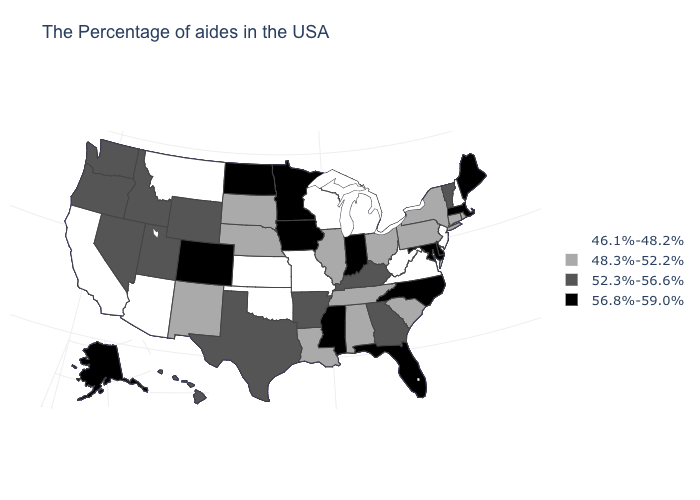What is the value of Pennsylvania?
Give a very brief answer. 48.3%-52.2%. What is the value of Wyoming?
Give a very brief answer. 52.3%-56.6%. Name the states that have a value in the range 56.8%-59.0%?
Answer briefly. Maine, Massachusetts, Delaware, Maryland, North Carolina, Florida, Indiana, Mississippi, Minnesota, Iowa, North Dakota, Colorado, Alaska. Does Tennessee have the same value as Vermont?
Keep it brief. No. What is the value of Montana?
Keep it brief. 46.1%-48.2%. How many symbols are there in the legend?
Concise answer only. 4. What is the lowest value in the USA?
Write a very short answer. 46.1%-48.2%. Does Mississippi have the lowest value in the South?
Write a very short answer. No. What is the lowest value in the MidWest?
Be succinct. 46.1%-48.2%. What is the highest value in the USA?
Be succinct. 56.8%-59.0%. Name the states that have a value in the range 52.3%-56.6%?
Answer briefly. Vermont, Georgia, Kentucky, Arkansas, Texas, Wyoming, Utah, Idaho, Nevada, Washington, Oregon, Hawaii. Which states hav the highest value in the West?
Concise answer only. Colorado, Alaska. Name the states that have a value in the range 48.3%-52.2%?
Give a very brief answer. Rhode Island, Connecticut, New York, Pennsylvania, South Carolina, Ohio, Alabama, Tennessee, Illinois, Louisiana, Nebraska, South Dakota, New Mexico. Does the map have missing data?
Quick response, please. No. Does Alabama have a lower value than Utah?
Answer briefly. Yes. 